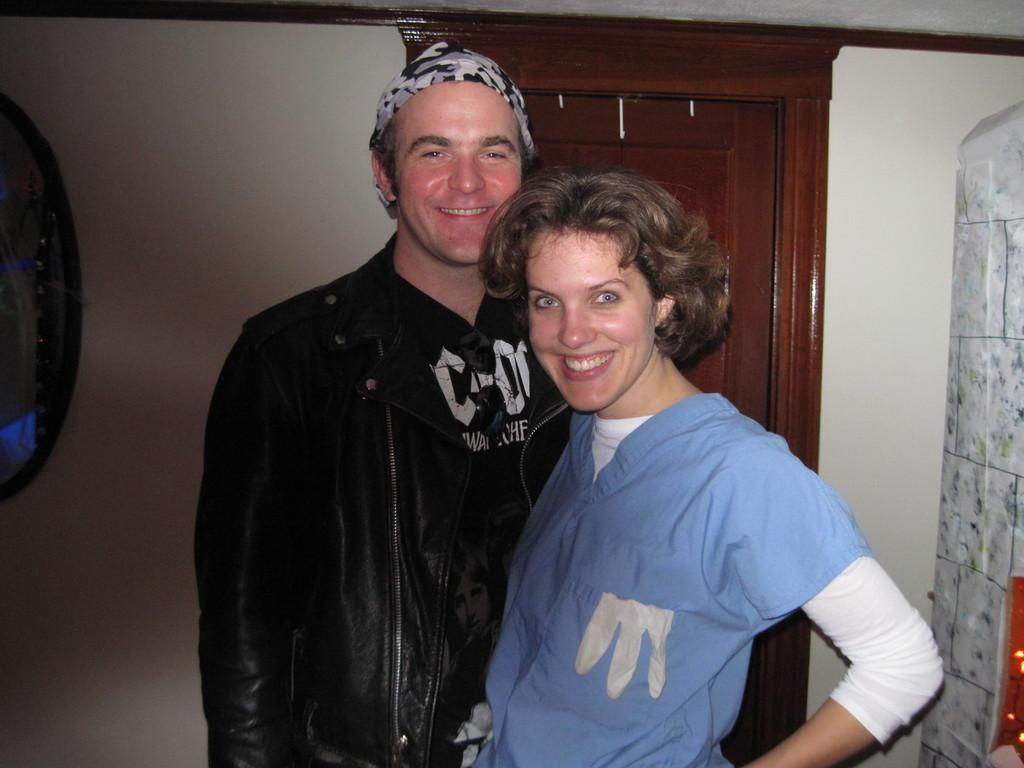Can you describe this image briefly? In the image there is a man and a woman both of them are smiling and posing for the photo and behind them there is wardrobe and in the background there is a wall. 